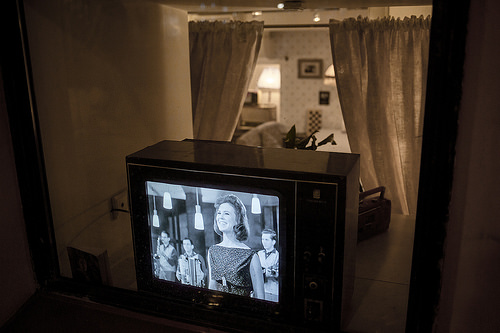<image>
Is there a picture in the tv? Yes. The picture is contained within or inside the tv, showing a containment relationship. 